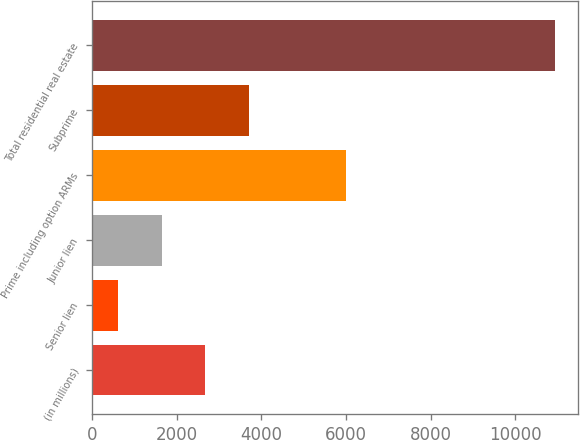Convert chart to OTSL. <chart><loc_0><loc_0><loc_500><loc_500><bar_chart><fcel>(in millions)<fcel>Senior lien<fcel>Junior lien<fcel>Prime including option ARMs<fcel>Subprime<fcel>Total residential real estate<nl><fcel>2676.2<fcel>610<fcel>1643.1<fcel>5989<fcel>3709.3<fcel>10941<nl></chart> 